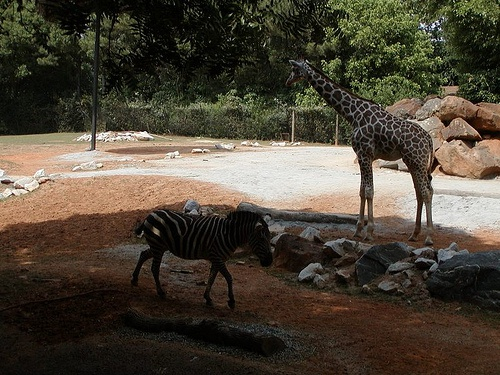Describe the objects in this image and their specific colors. I can see giraffe in black and gray tones and zebra in black and gray tones in this image. 